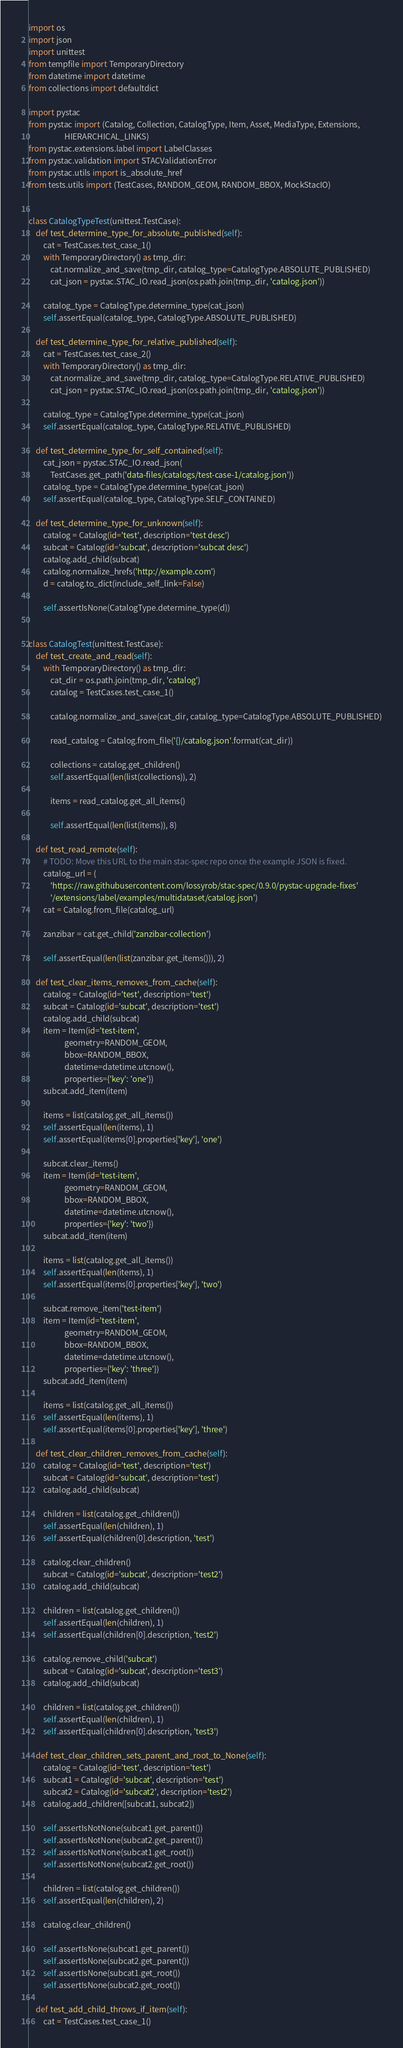<code> <loc_0><loc_0><loc_500><loc_500><_Python_>import os
import json
import unittest
from tempfile import TemporaryDirectory
from datetime import datetime
from collections import defaultdict

import pystac
from pystac import (Catalog, Collection, CatalogType, Item, Asset, MediaType, Extensions,
                    HIERARCHICAL_LINKS)
from pystac.extensions.label import LabelClasses
from pystac.validation import STACValidationError
from pystac.utils import is_absolute_href
from tests.utils import (TestCases, RANDOM_GEOM, RANDOM_BBOX, MockStacIO)


class CatalogTypeTest(unittest.TestCase):
    def test_determine_type_for_absolute_published(self):
        cat = TestCases.test_case_1()
        with TemporaryDirectory() as tmp_dir:
            cat.normalize_and_save(tmp_dir, catalog_type=CatalogType.ABSOLUTE_PUBLISHED)
            cat_json = pystac.STAC_IO.read_json(os.path.join(tmp_dir, 'catalog.json'))

        catalog_type = CatalogType.determine_type(cat_json)
        self.assertEqual(catalog_type, CatalogType.ABSOLUTE_PUBLISHED)

    def test_determine_type_for_relative_published(self):
        cat = TestCases.test_case_2()
        with TemporaryDirectory() as tmp_dir:
            cat.normalize_and_save(tmp_dir, catalog_type=CatalogType.RELATIVE_PUBLISHED)
            cat_json = pystac.STAC_IO.read_json(os.path.join(tmp_dir, 'catalog.json'))

        catalog_type = CatalogType.determine_type(cat_json)
        self.assertEqual(catalog_type, CatalogType.RELATIVE_PUBLISHED)

    def test_determine_type_for_self_contained(self):
        cat_json = pystac.STAC_IO.read_json(
            TestCases.get_path('data-files/catalogs/test-case-1/catalog.json'))
        catalog_type = CatalogType.determine_type(cat_json)
        self.assertEqual(catalog_type, CatalogType.SELF_CONTAINED)

    def test_determine_type_for_unknown(self):
        catalog = Catalog(id='test', description='test desc')
        subcat = Catalog(id='subcat', description='subcat desc')
        catalog.add_child(subcat)
        catalog.normalize_hrefs('http://example.com')
        d = catalog.to_dict(include_self_link=False)

        self.assertIsNone(CatalogType.determine_type(d))


class CatalogTest(unittest.TestCase):
    def test_create_and_read(self):
        with TemporaryDirectory() as tmp_dir:
            cat_dir = os.path.join(tmp_dir, 'catalog')
            catalog = TestCases.test_case_1()

            catalog.normalize_and_save(cat_dir, catalog_type=CatalogType.ABSOLUTE_PUBLISHED)

            read_catalog = Catalog.from_file('{}/catalog.json'.format(cat_dir))

            collections = catalog.get_children()
            self.assertEqual(len(list(collections)), 2)

            items = read_catalog.get_all_items()

            self.assertEqual(len(list(items)), 8)

    def test_read_remote(self):
        # TODO: Move this URL to the main stac-spec repo once the example JSON is fixed.
        catalog_url = (
            'https://raw.githubusercontent.com/lossyrob/stac-spec/0.9.0/pystac-upgrade-fixes'
            '/extensions/label/examples/multidataset/catalog.json')
        cat = Catalog.from_file(catalog_url)

        zanzibar = cat.get_child('zanzibar-collection')

        self.assertEqual(len(list(zanzibar.get_items())), 2)

    def test_clear_items_removes_from_cache(self):
        catalog = Catalog(id='test', description='test')
        subcat = Catalog(id='subcat', description='test')
        catalog.add_child(subcat)
        item = Item(id='test-item',
                    geometry=RANDOM_GEOM,
                    bbox=RANDOM_BBOX,
                    datetime=datetime.utcnow(),
                    properties={'key': 'one'})
        subcat.add_item(item)

        items = list(catalog.get_all_items())
        self.assertEqual(len(items), 1)
        self.assertEqual(items[0].properties['key'], 'one')

        subcat.clear_items()
        item = Item(id='test-item',
                    geometry=RANDOM_GEOM,
                    bbox=RANDOM_BBOX,
                    datetime=datetime.utcnow(),
                    properties={'key': 'two'})
        subcat.add_item(item)

        items = list(catalog.get_all_items())
        self.assertEqual(len(items), 1)
        self.assertEqual(items[0].properties['key'], 'two')

        subcat.remove_item('test-item')
        item = Item(id='test-item',
                    geometry=RANDOM_GEOM,
                    bbox=RANDOM_BBOX,
                    datetime=datetime.utcnow(),
                    properties={'key': 'three'})
        subcat.add_item(item)

        items = list(catalog.get_all_items())
        self.assertEqual(len(items), 1)
        self.assertEqual(items[0].properties['key'], 'three')

    def test_clear_children_removes_from_cache(self):
        catalog = Catalog(id='test', description='test')
        subcat = Catalog(id='subcat', description='test')
        catalog.add_child(subcat)

        children = list(catalog.get_children())
        self.assertEqual(len(children), 1)
        self.assertEqual(children[0].description, 'test')

        catalog.clear_children()
        subcat = Catalog(id='subcat', description='test2')
        catalog.add_child(subcat)

        children = list(catalog.get_children())
        self.assertEqual(len(children), 1)
        self.assertEqual(children[0].description, 'test2')

        catalog.remove_child('subcat')
        subcat = Catalog(id='subcat', description='test3')
        catalog.add_child(subcat)

        children = list(catalog.get_children())
        self.assertEqual(len(children), 1)
        self.assertEqual(children[0].description, 'test3')

    def test_clear_children_sets_parent_and_root_to_None(self):
        catalog = Catalog(id='test', description='test')
        subcat1 = Catalog(id='subcat', description='test')
        subcat2 = Catalog(id='subcat2', description='test2')
        catalog.add_children([subcat1, subcat2])

        self.assertIsNotNone(subcat1.get_parent())
        self.assertIsNotNone(subcat2.get_parent())
        self.assertIsNotNone(subcat1.get_root())
        self.assertIsNotNone(subcat2.get_root())

        children = list(catalog.get_children())
        self.assertEqual(len(children), 2)

        catalog.clear_children()

        self.assertIsNone(subcat1.get_parent())
        self.assertIsNone(subcat2.get_parent())
        self.assertIsNone(subcat1.get_root())
        self.assertIsNone(subcat2.get_root())

    def test_add_child_throws_if_item(self):
        cat = TestCases.test_case_1()</code> 